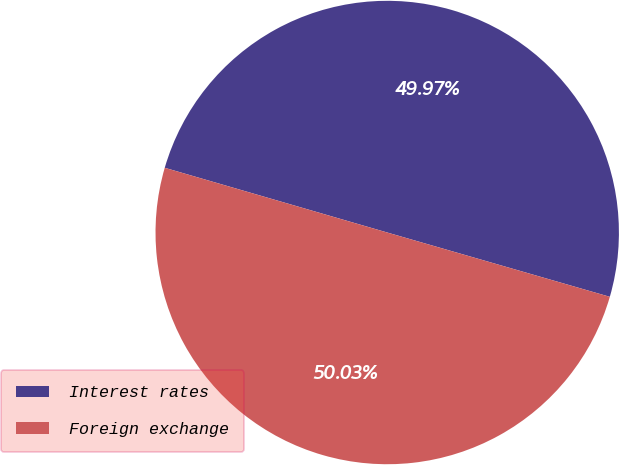Convert chart to OTSL. <chart><loc_0><loc_0><loc_500><loc_500><pie_chart><fcel>Interest rates<fcel>Foreign exchange<nl><fcel>49.97%<fcel>50.03%<nl></chart> 